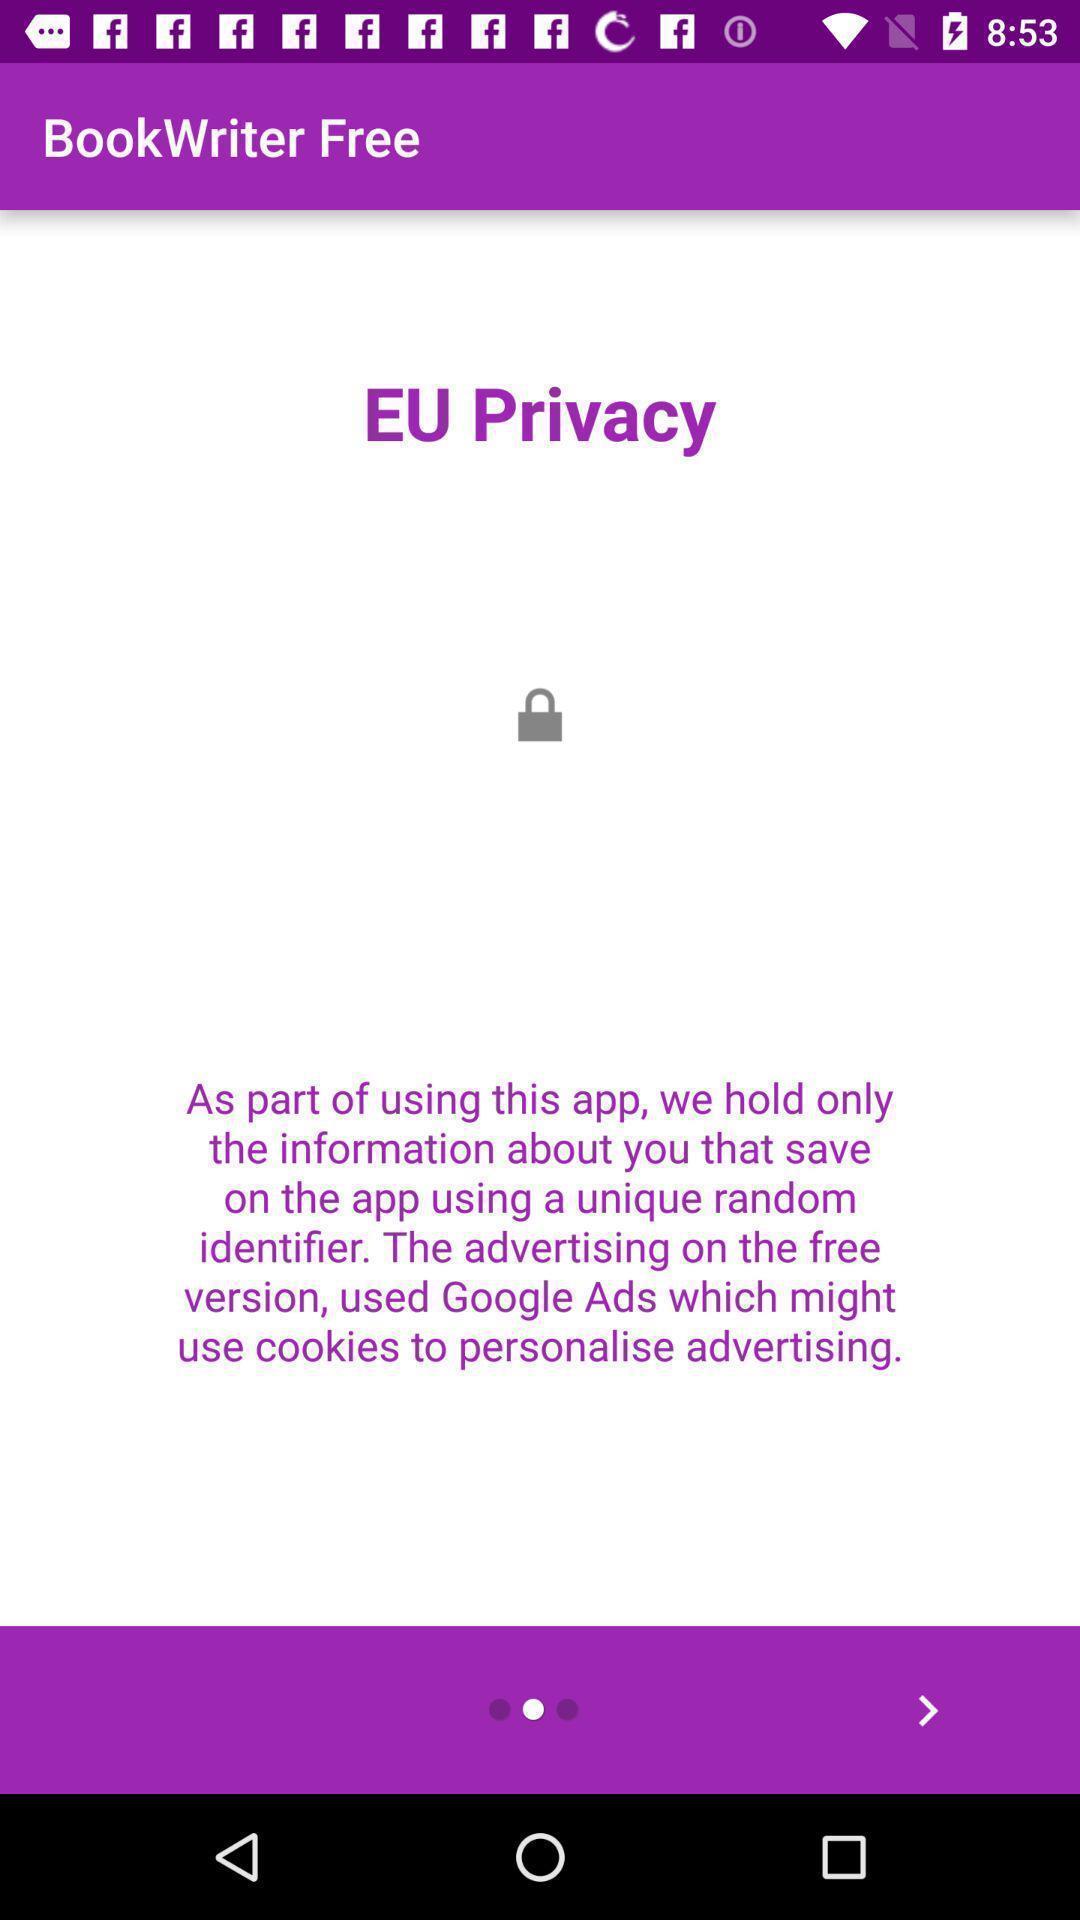Give me a narrative description of this picture. Start page of a book writing app. 